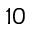Convert formula to latex. <formula><loc_0><loc_0><loc_500><loc_500>_ { 1 0 }</formula> 